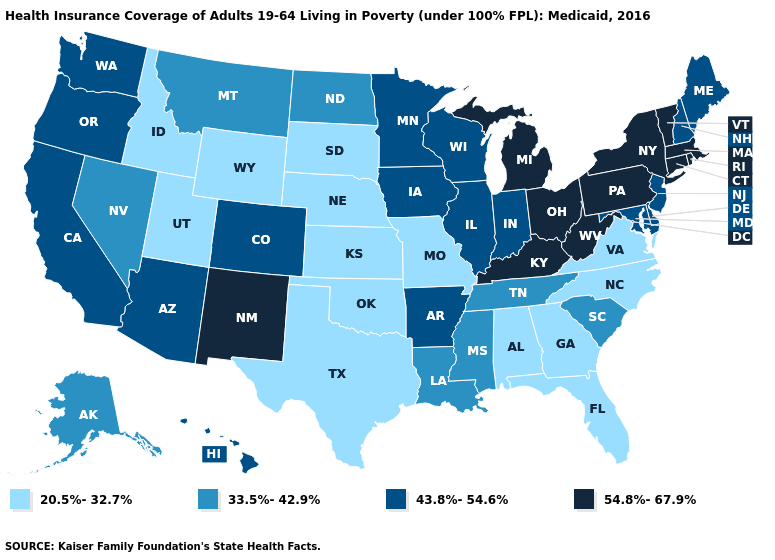What is the value of Colorado?
Keep it brief. 43.8%-54.6%. What is the value of Tennessee?
Write a very short answer. 33.5%-42.9%. Name the states that have a value in the range 20.5%-32.7%?
Concise answer only. Alabama, Florida, Georgia, Idaho, Kansas, Missouri, Nebraska, North Carolina, Oklahoma, South Dakota, Texas, Utah, Virginia, Wyoming. Which states hav the highest value in the Northeast?
Be succinct. Connecticut, Massachusetts, New York, Pennsylvania, Rhode Island, Vermont. What is the value of Virginia?
Short answer required. 20.5%-32.7%. Which states hav the highest value in the South?
Keep it brief. Kentucky, West Virginia. What is the value of West Virginia?
Quick response, please. 54.8%-67.9%. Which states hav the highest value in the South?
Short answer required. Kentucky, West Virginia. Among the states that border Georgia , which have the highest value?
Concise answer only. South Carolina, Tennessee. Does Louisiana have a lower value than Minnesota?
Give a very brief answer. Yes. Name the states that have a value in the range 43.8%-54.6%?
Quick response, please. Arizona, Arkansas, California, Colorado, Delaware, Hawaii, Illinois, Indiana, Iowa, Maine, Maryland, Minnesota, New Hampshire, New Jersey, Oregon, Washington, Wisconsin. What is the highest value in the USA?
Answer briefly. 54.8%-67.9%. Name the states that have a value in the range 54.8%-67.9%?
Write a very short answer. Connecticut, Kentucky, Massachusetts, Michigan, New Mexico, New York, Ohio, Pennsylvania, Rhode Island, Vermont, West Virginia. Does Mississippi have a lower value than West Virginia?
Answer briefly. Yes. 